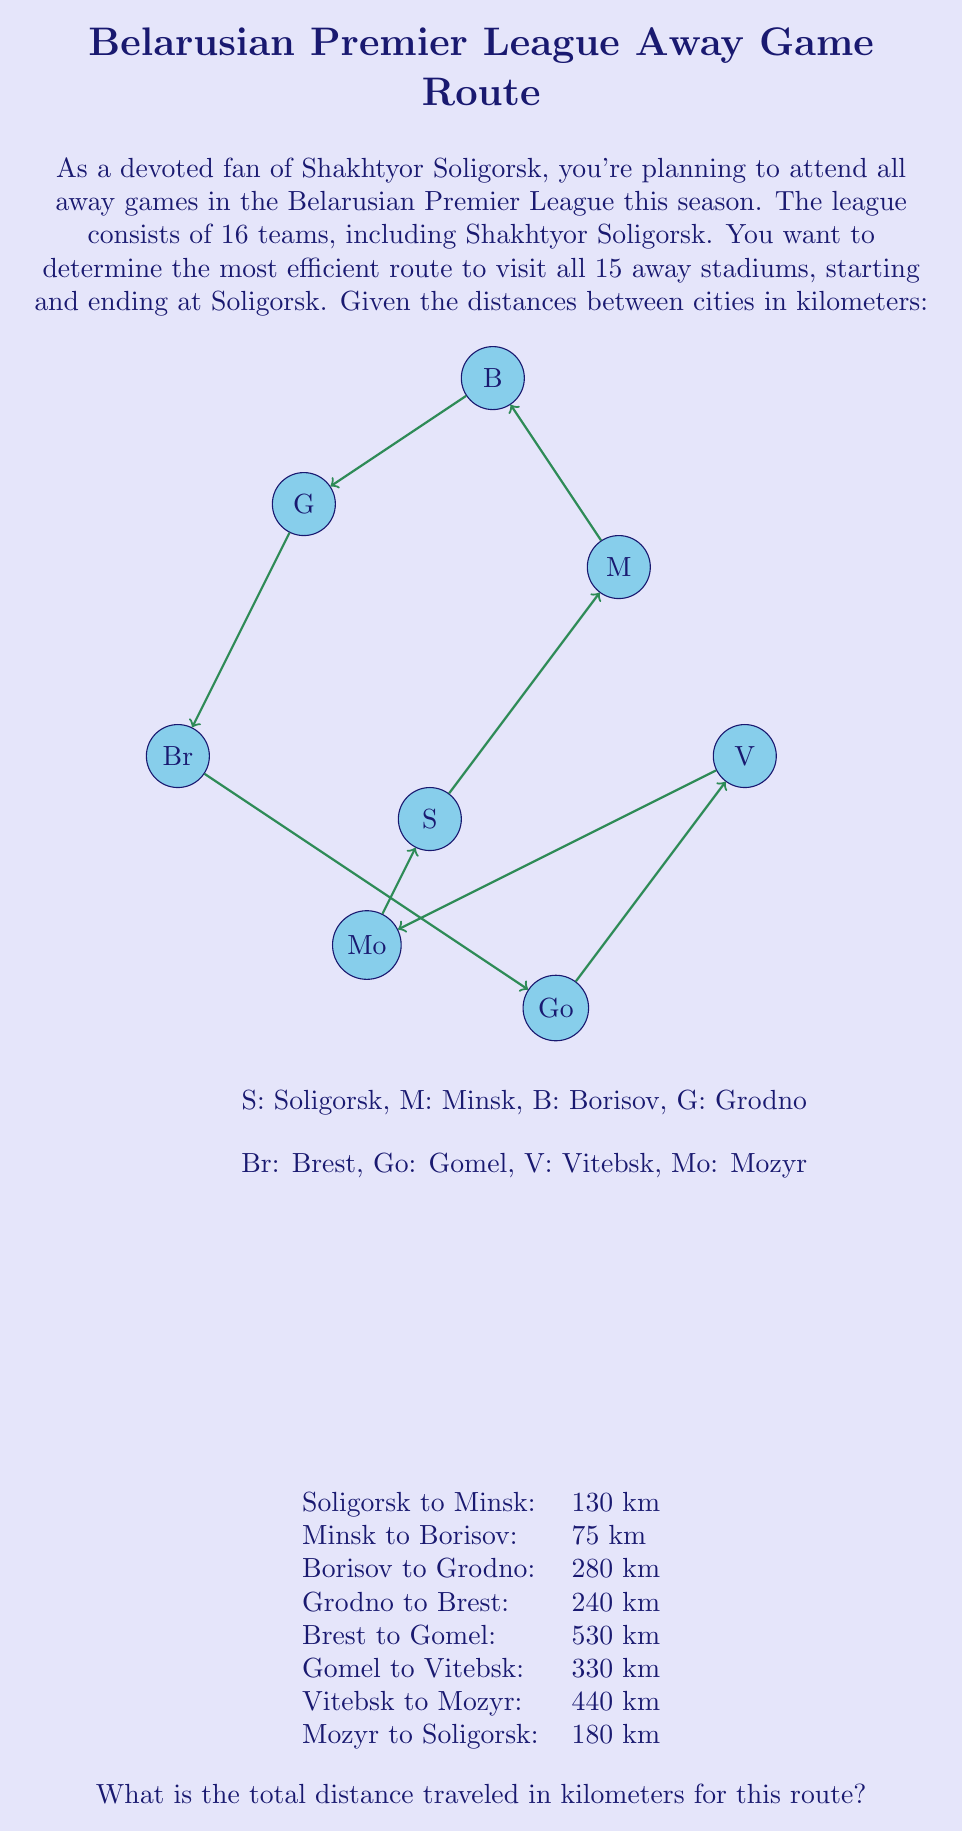Solve this math problem. To solve this problem, we need to sum up the distances between each consecutive city in the given route. Let's break it down step by step:

1. Soligorsk to Minsk: 130 km
2. Minsk to Borisov: 75 km
3. Borisov to Grodno: 280 km
4. Grodno to Brest: 240 km
5. Brest to Gomel: 530 km
6. Gomel to Vitebsk: 330 km
7. Vitebsk to Mozyr: 440 km
8. Mozyr to Soligorsk: 180 km

Now, let's add up all these distances:

$$\begin{align}
\text{Total distance} &= 130 + 75 + 280 + 240 + 530 + 330 + 440 + 180 \\
&= 2205 \text{ km}
\end{align}$$

Therefore, the total distance traveled in this route is 2205 kilometers.

Note: This route may not be the most optimal solution for the Traveling Salesman Problem, which would find the shortest possible route visiting all cities exactly once. The optimal solution would require more complex algorithms like the Held-Karp algorithm or heuristic methods.
Answer: 2205 km 